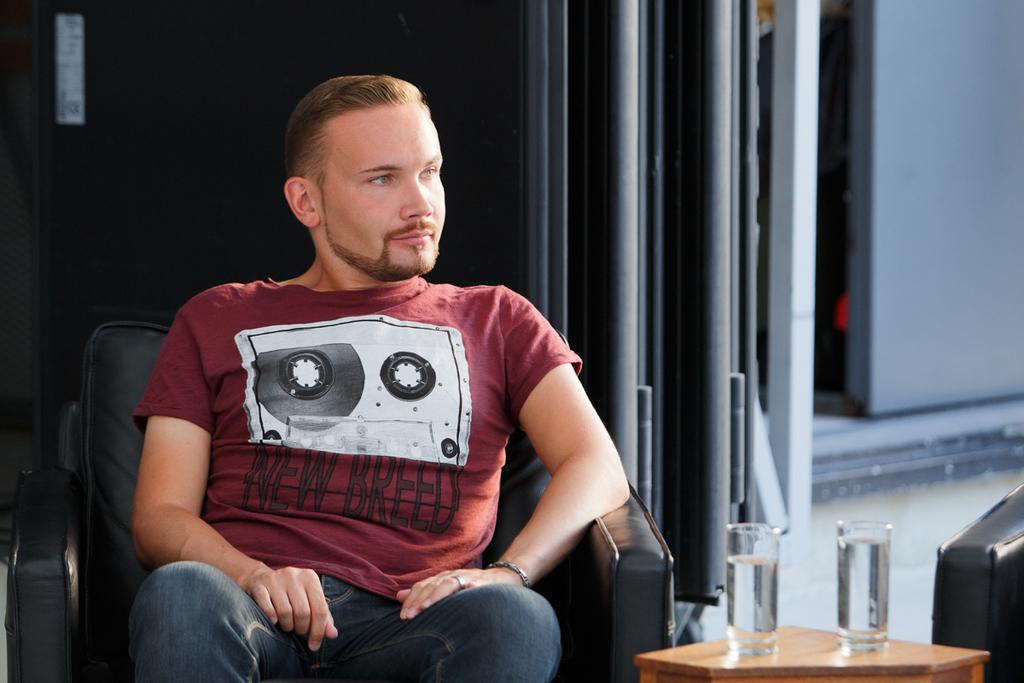Could you give a brief overview of what you see in this image? As we can see in the image there is a wall, man sitting on chair and a small table. On table there are two glasses. 